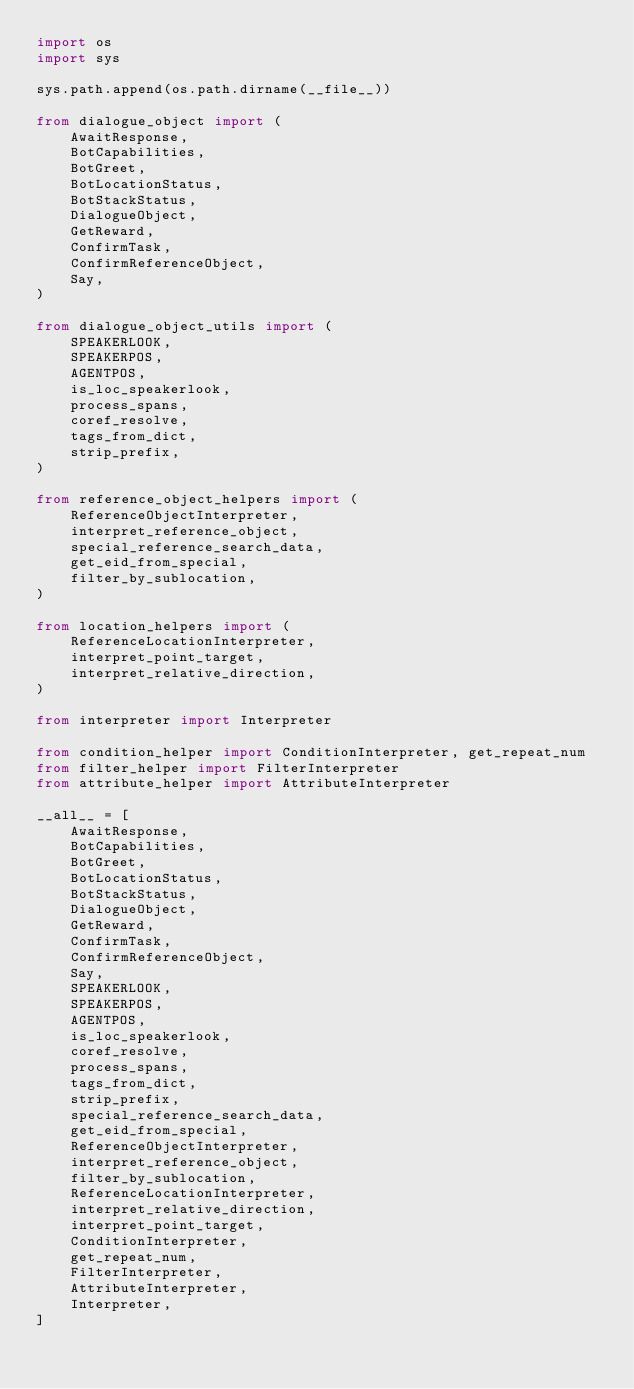Convert code to text. <code><loc_0><loc_0><loc_500><loc_500><_Python_>import os
import sys

sys.path.append(os.path.dirname(__file__))

from dialogue_object import (
    AwaitResponse,
    BotCapabilities,
    BotGreet,
    BotLocationStatus,
    BotStackStatus,
    DialogueObject,
    GetReward,
    ConfirmTask,
    ConfirmReferenceObject,
    Say,
)

from dialogue_object_utils import (
    SPEAKERLOOK,
    SPEAKERPOS,
    AGENTPOS,
    is_loc_speakerlook,
    process_spans,
    coref_resolve,
    tags_from_dict,
    strip_prefix,
)

from reference_object_helpers import (
    ReferenceObjectInterpreter,
    interpret_reference_object,
    special_reference_search_data,
    get_eid_from_special,
    filter_by_sublocation,
)

from location_helpers import (
    ReferenceLocationInterpreter,
    interpret_point_target,
    interpret_relative_direction,
)

from interpreter import Interpreter

from condition_helper import ConditionInterpreter, get_repeat_num
from filter_helper import FilterInterpreter
from attribute_helper import AttributeInterpreter

__all__ = [
    AwaitResponse,
    BotCapabilities,
    BotGreet,
    BotLocationStatus,
    BotStackStatus,
    DialogueObject,
    GetReward,
    ConfirmTask,
    ConfirmReferenceObject,
    Say,
    SPEAKERLOOK,
    SPEAKERPOS,
    AGENTPOS,
    is_loc_speakerlook,
    coref_resolve,
    process_spans,
    tags_from_dict,
    strip_prefix,
    special_reference_search_data,
    get_eid_from_special,
    ReferenceObjectInterpreter,
    interpret_reference_object,
    filter_by_sublocation,
    ReferenceLocationInterpreter,
    interpret_relative_direction,
    interpret_point_target,
    ConditionInterpreter,
    get_repeat_num,
    FilterInterpreter,
    AttributeInterpreter,
    Interpreter,
]
</code> 